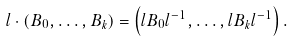Convert formula to latex. <formula><loc_0><loc_0><loc_500><loc_500>l \cdot \left ( B _ { 0 } , \dots , B _ { k } \right ) = \left ( l B _ { 0 } l ^ { - 1 } , \dots , l B _ { k } l ^ { - 1 } \right ) .</formula> 